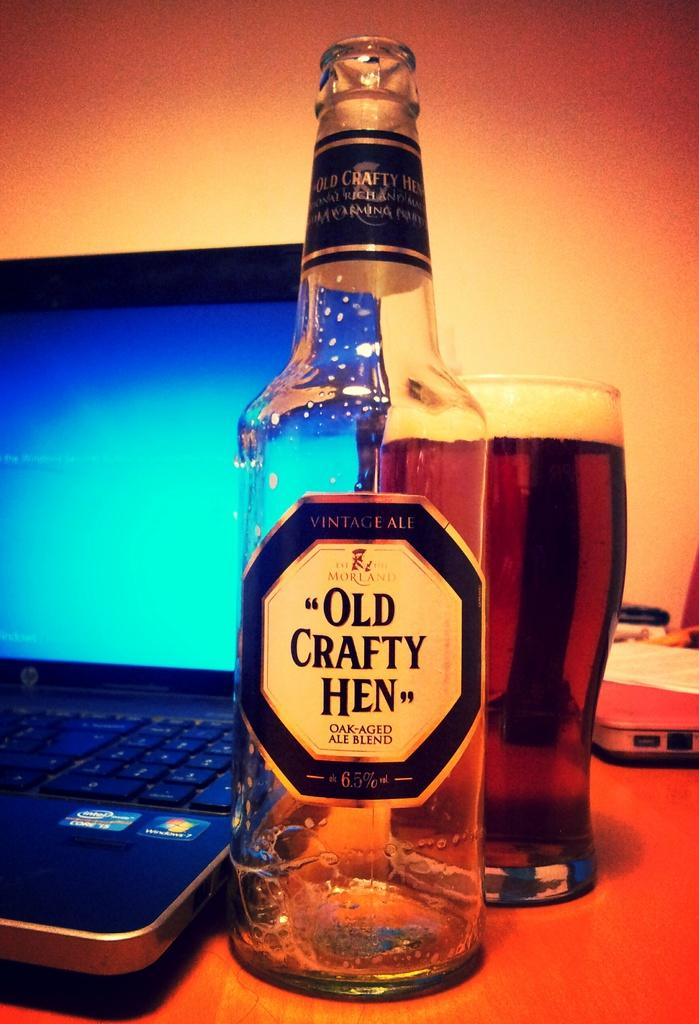What type of beverage container is present in the image? There is a wine bottle in the image. What is used for drinking the beverage in the image? There is a wine glass in the image. What electronic device can be seen on a table in the image? There is a laptop on a table in the image. What is displayed on the laptop screen in the image? There are objects on the laptop screen in the image. How many babies are present in the image? There are no babies present in the image. What type of mineral is used to create the wine glasses in the image? The image does not provide information about the composition of the wine glasses, so it cannot be determined if quartz is used. 